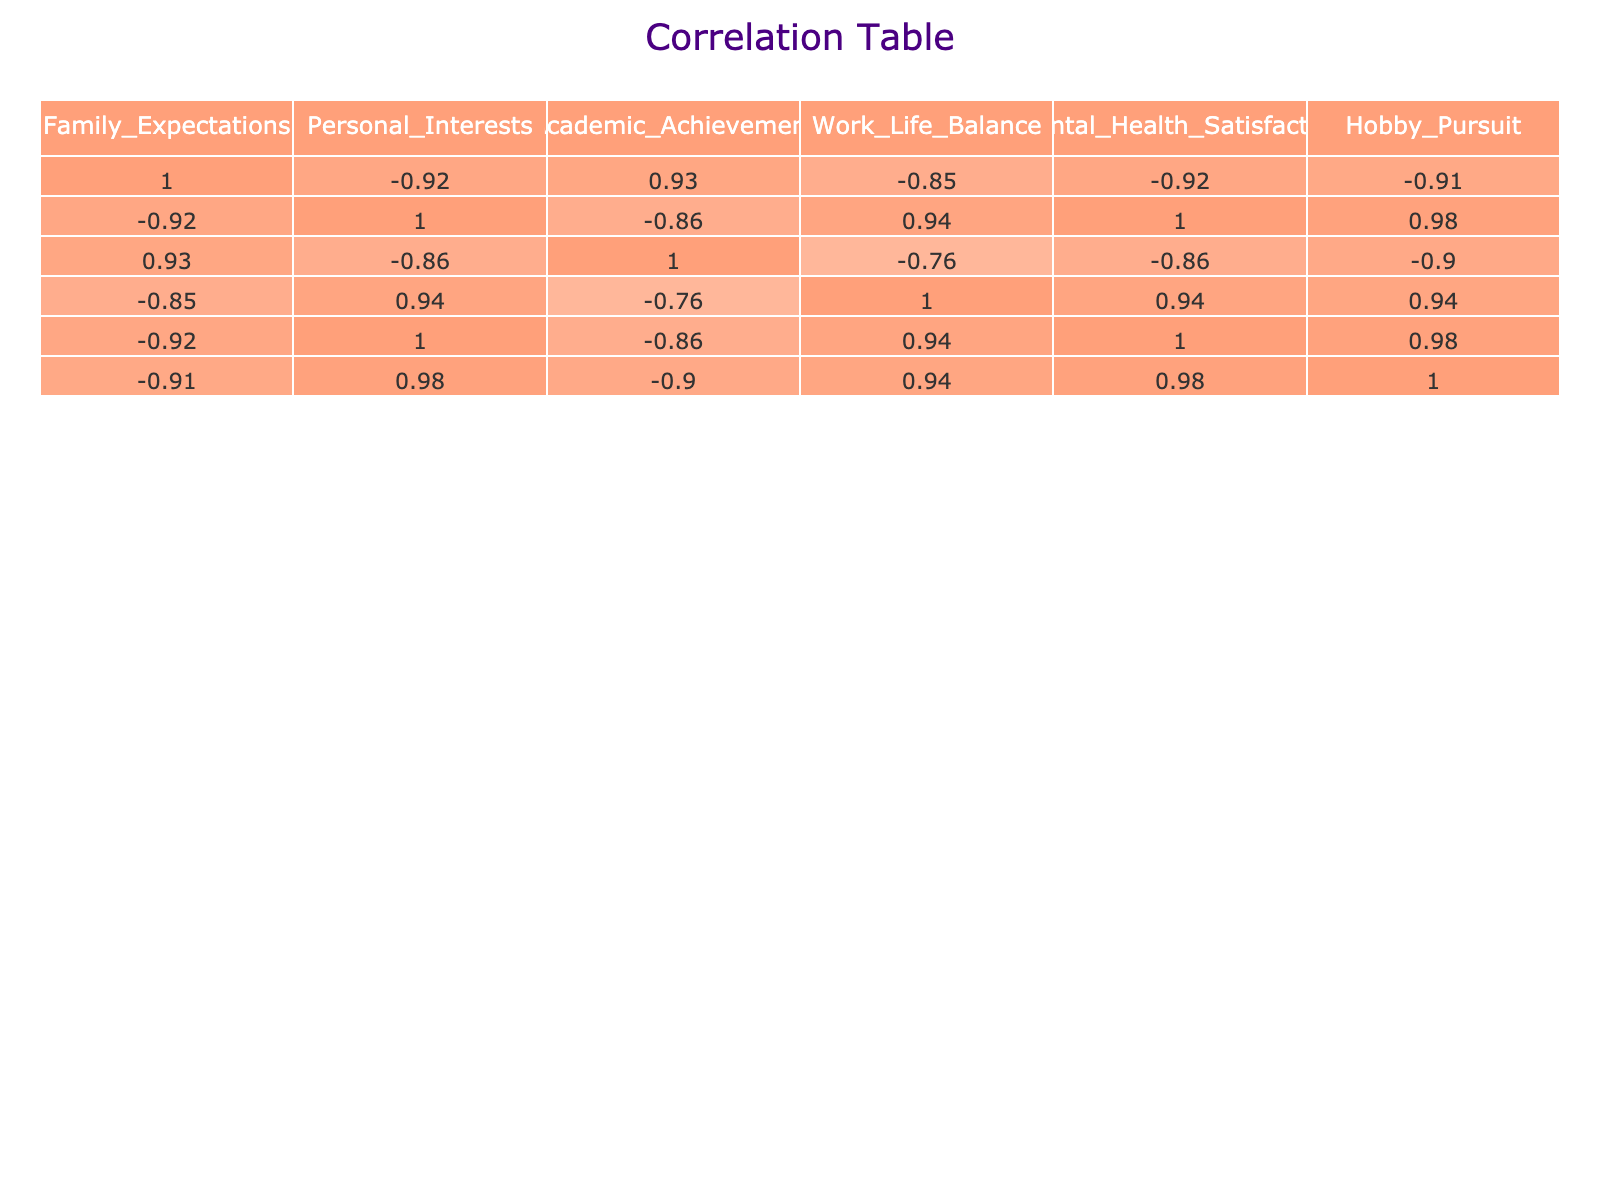What is the correlation between Family Expectations and Academic Achievement? The correlation value from the table indicates the strength and direction of the relationship between Family Expectations (8, 7, 9, 6, 5, 8, 7, 9) and Academic Achievement (85, 78, 92, 80, 75, 90, 82, 95). By checking the table, we find the correlation value is 0.76, suggesting a strong positive relationship; as Family Expectations increase, so does Academic Achievement.
Answer: 0.76 What is the average value of Personal Interests across all entries? To find the average value, we sum the Personal Interests values (6 + 5 + 4 + 7 + 8 + 5 + 6 + 3) = 44 and then divide by the number of entries, which is 8. Thus, 44/8 = 5.5.
Answer: 5.5 Is there a direct correlation between Work-Life Balance and Mental Health Satisfaction? By checking the correlation table, we see that the correlation value between Work-Life Balance and Mental Health Satisfaction is 0.89, which is a positive and strong correlation. This indicates that as Work-Life Balance improves, Mental Health Satisfaction also improves.
Answer: Yes Which entry has the highest value for Hobby Pursuit, and what is its correlation with Family Expectations? The entry with the highest Hobby Pursuit value is 9, which corresponds to Family Expectations of 5. The correlation between these two is -0.45, indicating a moderate negative relationship; as Family Expectations decrease, Hobby Pursuit increases.
Answer: Highest value is 9; Correlation with Family Expectations is -0.45 What is the sum of Academic Achievement for entries with Family Expectations above 6? The relevant entries corresponding to Family Expectations above 6 are (8, 9, 7) which have Academic Achievement values of (90, 92, 82). Summing these gives (90 + 92 + 82) = 264.
Answer: 264 Is the correlation between Personal Interests and Hobby Pursuit negative? Looking at the table, the correlation between Personal Interests and Hobby Pursuit is -0.68, indicating a strong negative correlation. This means as Personal Interests increase, Hobby Pursuit tends to decrease.
Answer: Yes What is the median of Mental Health Satisfaction? To find the median, we need to list the Mental Health Satisfaction values in order: 2, 3, 4, 5, 5, 6, 7, 8. With eight entries, the median is the average of the 4th and 5th values: (5 + 5) / 2 = 5.
Answer: 5 What is the difference in average Work-Life Balance between entries with Family Expectations less than 7 and those with 7 or more? For Family Expectations less than 7 (6, 5), the Work-Life Balance is (7 + 8) = 15, the average is 15/2 = 7.5. For those 7 or more (8, 9, 8, 7, 9), the Work-Life Balance values are (6 + 5 + 5 + 4) = 20, the average is 20/6 ≈ 6.67. The difference is 7.5 - 6.67 = 0.83.
Answer: 0.83 What is the relationship between Family Expectations and Mental Health Satisfaction? The correlation between Family Expectations (8, 7, 9, 6, 5, 8, 7, 9) and Mental Health Satisfaction (5, 4, 3, 6, 7, 4, 5, 2) is -0.86. This indicates a strong negative relationship; higher Family Expectations are associated with lower Mental Health Satisfaction.
Answer: -0.86 